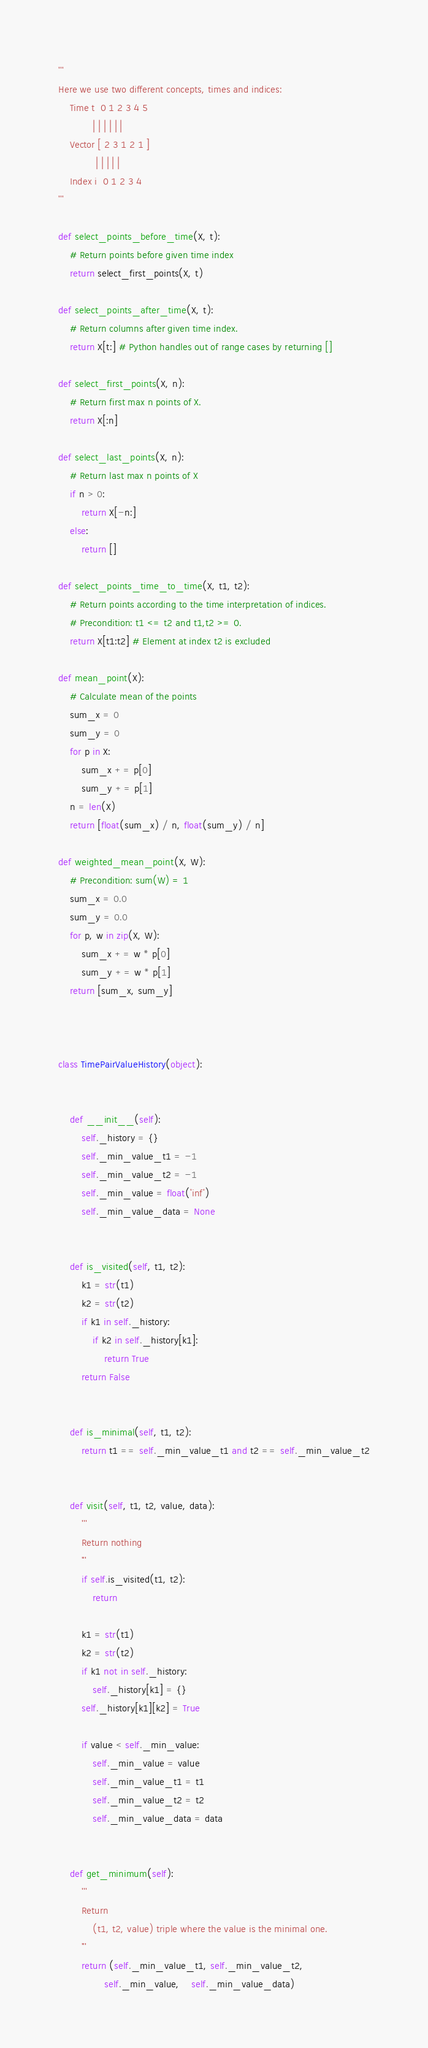Convert code to text. <code><loc_0><loc_0><loc_500><loc_500><_Python_>'''
Here we use two different concepts, times and indices:
    Time t  0 1 2 3 4 5
            | | | | | |
    Vector [ 2 3 1 2 1 ]
             | | | | |
    Index i  0 1 2 3 4
'''

def select_points_before_time(X, t):
    # Return points before given time index
    return select_first_points(X, t)

def select_points_after_time(X, t):
    # Return columns after given time index.
    return X[t:] # Python handles out of range cases by returning []

def select_first_points(X, n):
    # Return first max n points of X.
    return X[:n]

def select_last_points(X, n):
    # Return last max n points of X
    if n > 0:
        return X[-n:]
    else:
        return []

def select_points_time_to_time(X, t1, t2):
    # Return points according to the time interpretation of indices.
    # Precondition: t1 <= t2 and t1,t2 >= 0.
    return X[t1:t2] # Element at index t2 is excluded

def mean_point(X):
    # Calculate mean of the points
    sum_x = 0
    sum_y = 0
    for p in X:
        sum_x += p[0]
        sum_y += p[1]
    n = len(X)
    return [float(sum_x) / n, float(sum_y) / n]

def weighted_mean_point(X, W):
    # Precondition: sum(W) = 1
    sum_x = 0.0
    sum_y = 0.0
    for p, w in zip(X, W):
        sum_x += w * p[0]
        sum_y += w * p[1]
    return [sum_x, sum_y]



class TimePairValueHistory(object):


    def __init__(self):
        self._history = {}
        self._min_value_t1 = -1
        self._min_value_t2 = -1
        self._min_value = float('inf')
        self._min_value_data = None


    def is_visited(self, t1, t2):
        k1 = str(t1)
        k2 = str(t2)
        if k1 in self._history:
            if k2 in self._history[k1]:
                return True
        return False


    def is_minimal(self, t1, t2):
        return t1 == self._min_value_t1 and t2 == self._min_value_t2


    def visit(self, t1, t2, value, data):
        '''
        Return nothing
        '''
        if self.is_visited(t1, t2):
            return

        k1 = str(t1)
        k2 = str(t2)
        if k1 not in self._history:
            self._history[k1] = {}
        self._history[k1][k2] = True

        if value < self._min_value:
            self._min_value = value
            self._min_value_t1 = t1
            self._min_value_t2 = t2
            self._min_value_data = data


    def get_minimum(self):
        '''
        Return
            (t1, t2, value) triple where the value is the minimal one.
        '''
        return (self._min_value_t1, self._min_value_t2,
                self._min_value,    self._min_value_data)
</code> 